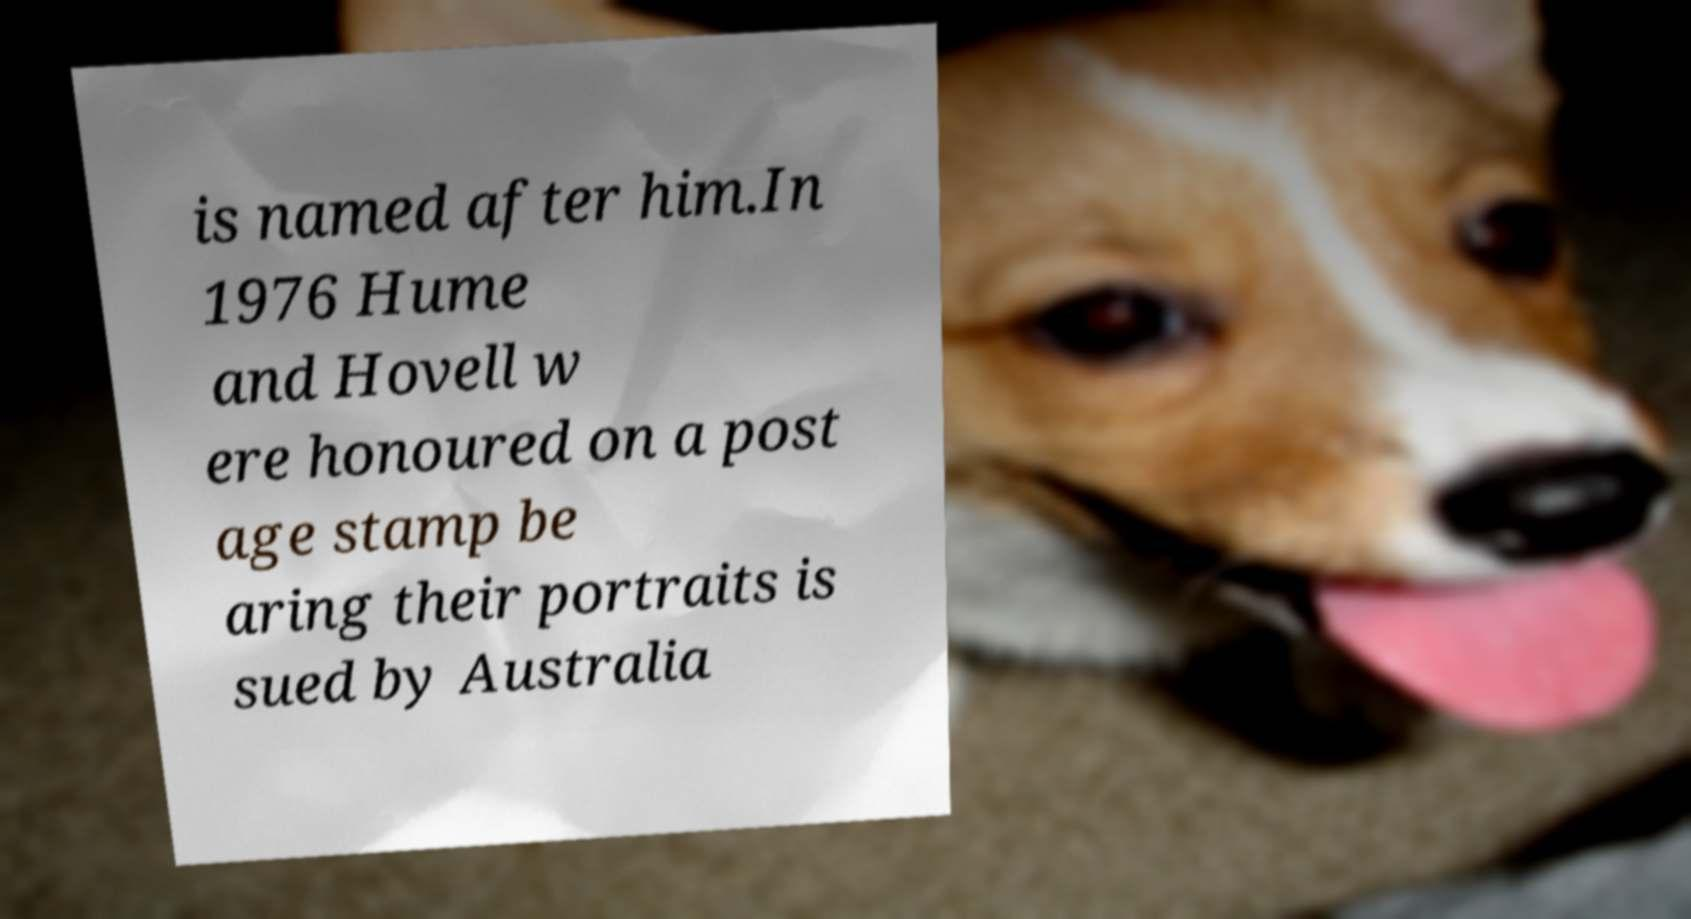I need the written content from this picture converted into text. Can you do that? is named after him.In 1976 Hume and Hovell w ere honoured on a post age stamp be aring their portraits is sued by Australia 